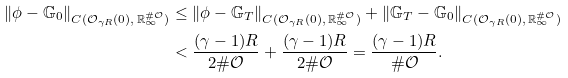Convert formula to latex. <formula><loc_0><loc_0><loc_500><loc_500>\| \phi - \mathbb { G } _ { 0 } \| _ { C ( \mathcal { O } _ { \gamma R } ( 0 ) , \, \mathbb { R } _ { \infty } ^ { \# \mathcal { O } } ) } & \leq \| \phi - \mathbb { G } _ { T } \| _ { C ( \mathcal { O } _ { \gamma R } ( 0 ) , \, \mathbb { R } _ { \infty } ^ { \# \mathcal { O } } ) } + \| \mathbb { G } _ { T } - \mathbb { G } _ { 0 } \| _ { C ( \mathcal { O } _ { \gamma R } ( 0 ) , \, \mathbb { R } _ { \infty } ^ { \# \mathcal { O } } ) } \\ & < \frac { ( \gamma - 1 ) R } { 2 \# \mathcal { O } } + \frac { ( \gamma - 1 ) R } { 2 \# \mathcal { O } } = \frac { ( \gamma - 1 ) R } { \# \mathcal { O } } .</formula> 